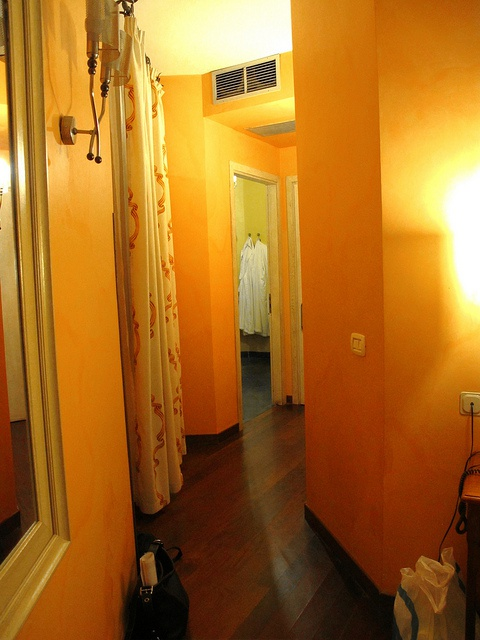Describe the objects in this image and their specific colors. I can see a handbag in olive, black, and maroon tones in this image. 